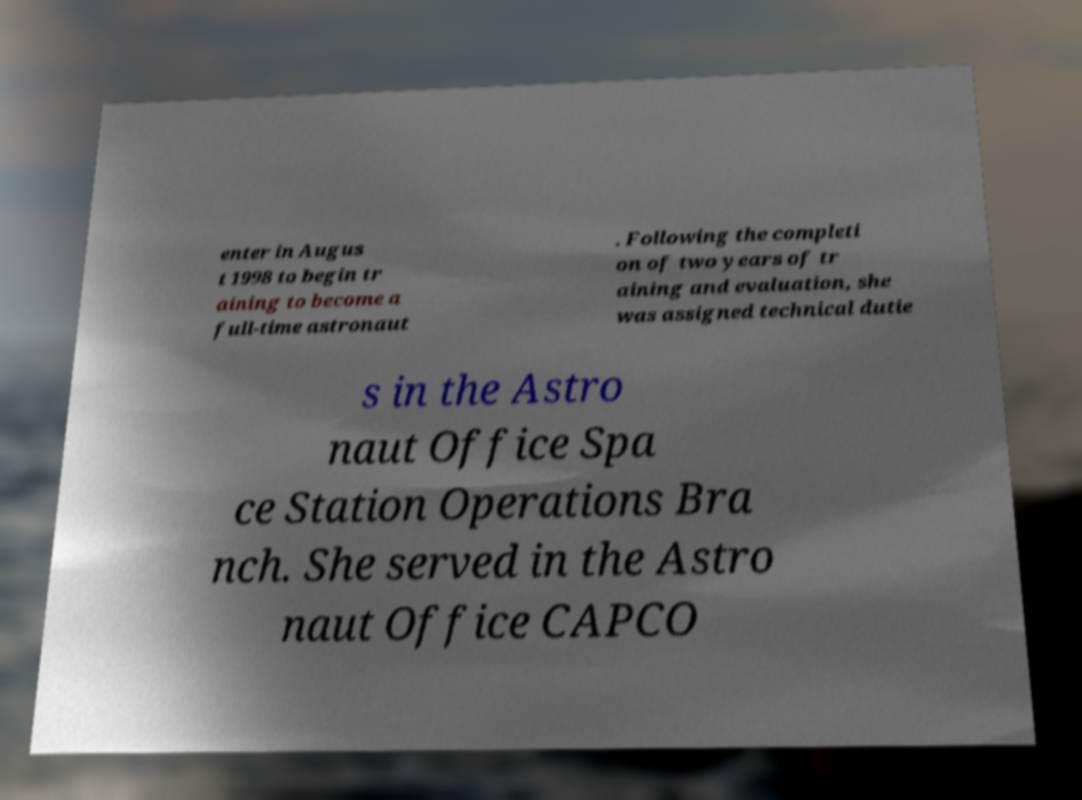Please read and relay the text visible in this image. What does it say? enter in Augus t 1998 to begin tr aining to become a full-time astronaut . Following the completi on of two years of tr aining and evaluation, she was assigned technical dutie s in the Astro naut Office Spa ce Station Operations Bra nch. She served in the Astro naut Office CAPCO 